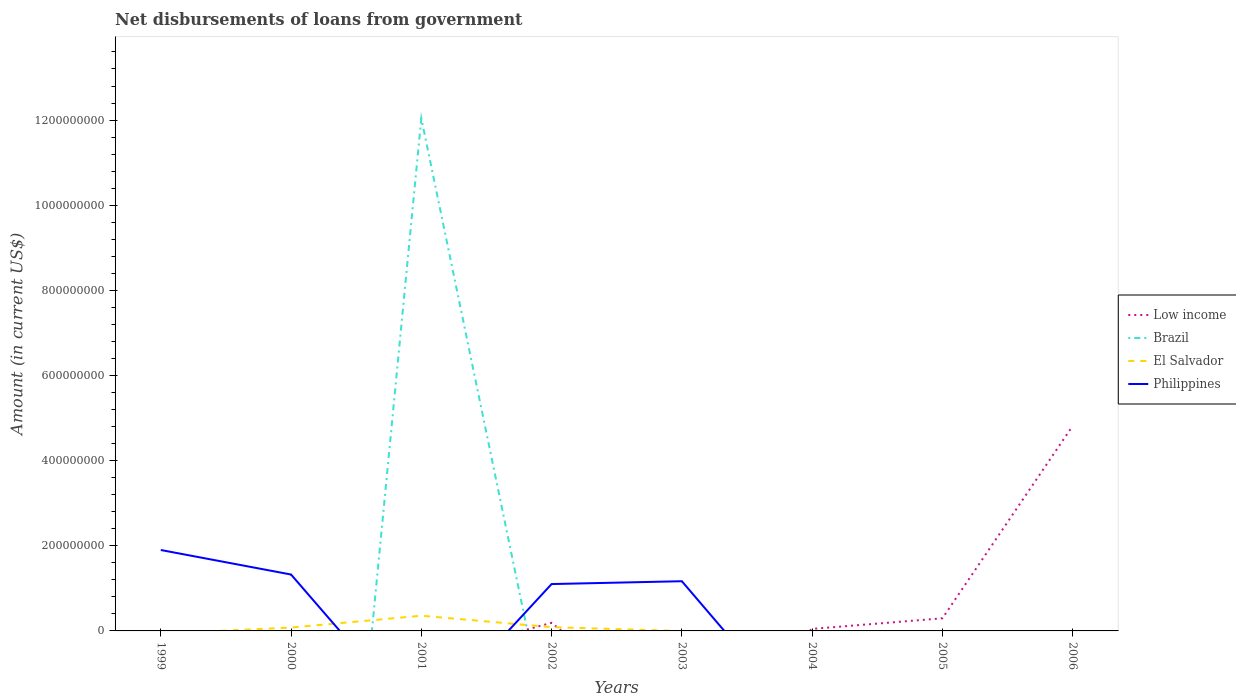How many different coloured lines are there?
Offer a very short reply. 4. Is the number of lines equal to the number of legend labels?
Provide a succinct answer. No. What is the total amount of loan disbursed from government in Low income in the graph?
Offer a very short reply. -2.49e+07. What is the difference between the highest and the second highest amount of loan disbursed from government in Brazil?
Provide a short and direct response. 1.20e+09. Is the amount of loan disbursed from government in Philippines strictly greater than the amount of loan disbursed from government in El Salvador over the years?
Your response must be concise. No. Does the graph contain any zero values?
Your answer should be compact. Yes. Does the graph contain grids?
Your answer should be compact. No. Where does the legend appear in the graph?
Your answer should be compact. Center right. How are the legend labels stacked?
Make the answer very short. Vertical. What is the title of the graph?
Your answer should be compact. Net disbursements of loans from government. What is the label or title of the X-axis?
Provide a succinct answer. Years. What is the Amount (in current US$) in Brazil in 1999?
Provide a succinct answer. 0. What is the Amount (in current US$) of El Salvador in 1999?
Your answer should be very brief. 0. What is the Amount (in current US$) in Philippines in 1999?
Your answer should be very brief. 1.90e+08. What is the Amount (in current US$) of Low income in 2000?
Your answer should be compact. 0. What is the Amount (in current US$) of Brazil in 2000?
Provide a short and direct response. 0. What is the Amount (in current US$) of El Salvador in 2000?
Your response must be concise. 7.85e+06. What is the Amount (in current US$) in Philippines in 2000?
Give a very brief answer. 1.32e+08. What is the Amount (in current US$) of Low income in 2001?
Provide a short and direct response. 0. What is the Amount (in current US$) of Brazil in 2001?
Your response must be concise. 1.20e+09. What is the Amount (in current US$) in El Salvador in 2001?
Your response must be concise. 3.57e+07. What is the Amount (in current US$) of Philippines in 2001?
Provide a succinct answer. 0. What is the Amount (in current US$) of Low income in 2002?
Give a very brief answer. 1.90e+07. What is the Amount (in current US$) in El Salvador in 2002?
Give a very brief answer. 8.84e+06. What is the Amount (in current US$) in Philippines in 2002?
Your response must be concise. 1.10e+08. What is the Amount (in current US$) in Brazil in 2003?
Make the answer very short. 0. What is the Amount (in current US$) in El Salvador in 2003?
Ensure brevity in your answer.  0. What is the Amount (in current US$) of Philippines in 2003?
Provide a succinct answer. 1.17e+08. What is the Amount (in current US$) of Low income in 2004?
Make the answer very short. 4.73e+06. What is the Amount (in current US$) of El Salvador in 2004?
Make the answer very short. 0. What is the Amount (in current US$) of Low income in 2005?
Make the answer very short. 2.97e+07. What is the Amount (in current US$) of Brazil in 2005?
Provide a succinct answer. 0. What is the Amount (in current US$) of Philippines in 2005?
Ensure brevity in your answer.  0. What is the Amount (in current US$) in Low income in 2006?
Your response must be concise. 4.82e+08. What is the Amount (in current US$) in Philippines in 2006?
Your answer should be very brief. 0. Across all years, what is the maximum Amount (in current US$) of Low income?
Provide a succinct answer. 4.82e+08. Across all years, what is the maximum Amount (in current US$) of Brazil?
Provide a short and direct response. 1.20e+09. Across all years, what is the maximum Amount (in current US$) in El Salvador?
Ensure brevity in your answer.  3.57e+07. Across all years, what is the maximum Amount (in current US$) of Philippines?
Make the answer very short. 1.90e+08. Across all years, what is the minimum Amount (in current US$) in Low income?
Your answer should be compact. 0. What is the total Amount (in current US$) in Low income in the graph?
Your answer should be very brief. 5.35e+08. What is the total Amount (in current US$) in Brazil in the graph?
Your answer should be compact. 1.20e+09. What is the total Amount (in current US$) of El Salvador in the graph?
Your answer should be compact. 5.24e+07. What is the total Amount (in current US$) in Philippines in the graph?
Offer a terse response. 5.49e+08. What is the difference between the Amount (in current US$) in Philippines in 1999 and that in 2000?
Keep it short and to the point. 5.76e+07. What is the difference between the Amount (in current US$) of Philippines in 1999 and that in 2002?
Offer a terse response. 8.00e+07. What is the difference between the Amount (in current US$) in Philippines in 1999 and that in 2003?
Offer a terse response. 7.33e+07. What is the difference between the Amount (in current US$) in El Salvador in 2000 and that in 2001?
Your response must be concise. -2.79e+07. What is the difference between the Amount (in current US$) of El Salvador in 2000 and that in 2002?
Offer a terse response. -9.88e+05. What is the difference between the Amount (in current US$) in Philippines in 2000 and that in 2002?
Make the answer very short. 2.24e+07. What is the difference between the Amount (in current US$) in Philippines in 2000 and that in 2003?
Provide a short and direct response. 1.57e+07. What is the difference between the Amount (in current US$) of El Salvador in 2001 and that in 2002?
Make the answer very short. 2.69e+07. What is the difference between the Amount (in current US$) in Philippines in 2002 and that in 2003?
Make the answer very short. -6.67e+06. What is the difference between the Amount (in current US$) of Low income in 2002 and that in 2004?
Provide a short and direct response. 1.43e+07. What is the difference between the Amount (in current US$) in Low income in 2002 and that in 2005?
Your answer should be very brief. -1.06e+07. What is the difference between the Amount (in current US$) in Low income in 2002 and that in 2006?
Provide a succinct answer. -4.63e+08. What is the difference between the Amount (in current US$) of Low income in 2004 and that in 2005?
Your response must be concise. -2.49e+07. What is the difference between the Amount (in current US$) in Low income in 2004 and that in 2006?
Make the answer very short. -4.77e+08. What is the difference between the Amount (in current US$) of Low income in 2005 and that in 2006?
Offer a terse response. -4.52e+08. What is the difference between the Amount (in current US$) of El Salvador in 2000 and the Amount (in current US$) of Philippines in 2002?
Your answer should be very brief. -1.02e+08. What is the difference between the Amount (in current US$) of El Salvador in 2000 and the Amount (in current US$) of Philippines in 2003?
Your answer should be compact. -1.09e+08. What is the difference between the Amount (in current US$) in Brazil in 2001 and the Amount (in current US$) in El Salvador in 2002?
Keep it short and to the point. 1.20e+09. What is the difference between the Amount (in current US$) in Brazil in 2001 and the Amount (in current US$) in Philippines in 2002?
Keep it short and to the point. 1.09e+09. What is the difference between the Amount (in current US$) in El Salvador in 2001 and the Amount (in current US$) in Philippines in 2002?
Your answer should be very brief. -7.44e+07. What is the difference between the Amount (in current US$) in Brazil in 2001 and the Amount (in current US$) in Philippines in 2003?
Keep it short and to the point. 1.09e+09. What is the difference between the Amount (in current US$) of El Salvador in 2001 and the Amount (in current US$) of Philippines in 2003?
Provide a succinct answer. -8.10e+07. What is the difference between the Amount (in current US$) of Low income in 2002 and the Amount (in current US$) of Philippines in 2003?
Give a very brief answer. -9.77e+07. What is the difference between the Amount (in current US$) of El Salvador in 2002 and the Amount (in current US$) of Philippines in 2003?
Provide a succinct answer. -1.08e+08. What is the average Amount (in current US$) in Low income per year?
Your answer should be compact. 6.69e+07. What is the average Amount (in current US$) in Brazil per year?
Give a very brief answer. 1.51e+08. What is the average Amount (in current US$) of El Salvador per year?
Keep it short and to the point. 6.55e+06. What is the average Amount (in current US$) in Philippines per year?
Make the answer very short. 6.87e+07. In the year 2000, what is the difference between the Amount (in current US$) of El Salvador and Amount (in current US$) of Philippines?
Ensure brevity in your answer.  -1.25e+08. In the year 2001, what is the difference between the Amount (in current US$) in Brazil and Amount (in current US$) in El Salvador?
Your response must be concise. 1.17e+09. In the year 2002, what is the difference between the Amount (in current US$) of Low income and Amount (in current US$) of El Salvador?
Provide a short and direct response. 1.02e+07. In the year 2002, what is the difference between the Amount (in current US$) of Low income and Amount (in current US$) of Philippines?
Offer a very short reply. -9.10e+07. In the year 2002, what is the difference between the Amount (in current US$) in El Salvador and Amount (in current US$) in Philippines?
Give a very brief answer. -1.01e+08. What is the ratio of the Amount (in current US$) in Philippines in 1999 to that in 2000?
Ensure brevity in your answer.  1.43. What is the ratio of the Amount (in current US$) in Philippines in 1999 to that in 2002?
Your response must be concise. 1.73. What is the ratio of the Amount (in current US$) in Philippines in 1999 to that in 2003?
Your response must be concise. 1.63. What is the ratio of the Amount (in current US$) of El Salvador in 2000 to that in 2001?
Your response must be concise. 0.22. What is the ratio of the Amount (in current US$) in El Salvador in 2000 to that in 2002?
Your response must be concise. 0.89. What is the ratio of the Amount (in current US$) in Philippines in 2000 to that in 2002?
Make the answer very short. 1.2. What is the ratio of the Amount (in current US$) in Philippines in 2000 to that in 2003?
Provide a short and direct response. 1.13. What is the ratio of the Amount (in current US$) of El Salvador in 2001 to that in 2002?
Your answer should be very brief. 4.04. What is the ratio of the Amount (in current US$) of Philippines in 2002 to that in 2003?
Offer a terse response. 0.94. What is the ratio of the Amount (in current US$) in Low income in 2002 to that in 2004?
Keep it short and to the point. 4.02. What is the ratio of the Amount (in current US$) in Low income in 2002 to that in 2005?
Keep it short and to the point. 0.64. What is the ratio of the Amount (in current US$) in Low income in 2002 to that in 2006?
Your response must be concise. 0.04. What is the ratio of the Amount (in current US$) in Low income in 2004 to that in 2005?
Your answer should be very brief. 0.16. What is the ratio of the Amount (in current US$) in Low income in 2004 to that in 2006?
Your answer should be very brief. 0.01. What is the ratio of the Amount (in current US$) of Low income in 2005 to that in 2006?
Your response must be concise. 0.06. What is the difference between the highest and the second highest Amount (in current US$) of Low income?
Make the answer very short. 4.52e+08. What is the difference between the highest and the second highest Amount (in current US$) of El Salvador?
Offer a terse response. 2.69e+07. What is the difference between the highest and the second highest Amount (in current US$) in Philippines?
Give a very brief answer. 5.76e+07. What is the difference between the highest and the lowest Amount (in current US$) in Low income?
Offer a very short reply. 4.82e+08. What is the difference between the highest and the lowest Amount (in current US$) in Brazil?
Keep it short and to the point. 1.20e+09. What is the difference between the highest and the lowest Amount (in current US$) of El Salvador?
Your response must be concise. 3.57e+07. What is the difference between the highest and the lowest Amount (in current US$) in Philippines?
Ensure brevity in your answer.  1.90e+08. 